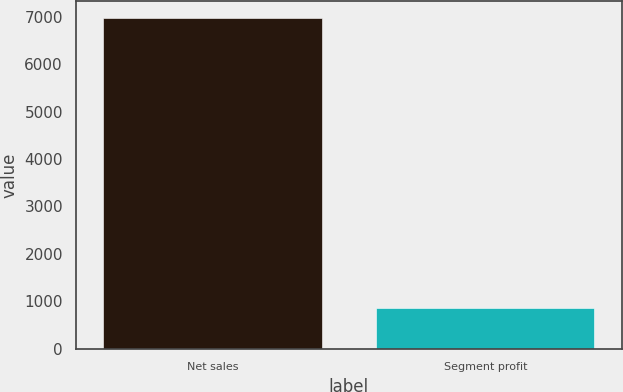<chart> <loc_0><loc_0><loc_500><loc_500><bar_chart><fcel>Net sales<fcel>Segment profit<nl><fcel>6978<fcel>860<nl></chart> 